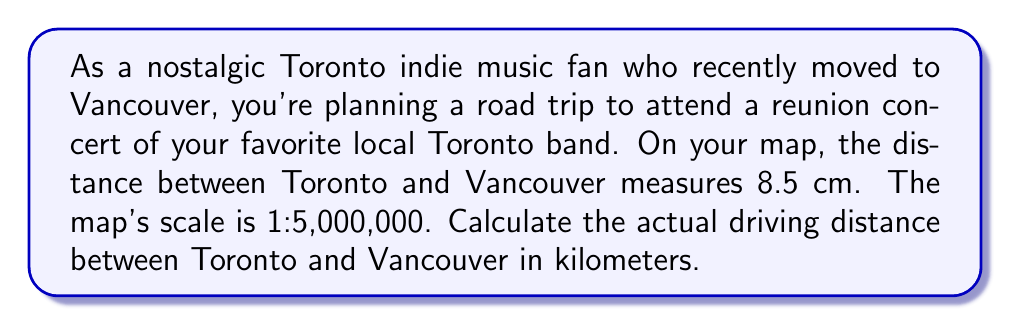Give your solution to this math problem. To solve this problem, we need to use the map scale to convert the measured distance on the map to the actual distance in kilometers. Let's break it down step-by-step:

1. Understand the map scale:
   The scale 1:5,000,000 means that 1 unit on the map represents 5,000,000 units in real life.

2. Convert the map measurement to real-life distance:
   - Map distance = 8.5 cm
   - Real distance = 8.5 × 5,000,000 cm

3. Calculate the real distance:
   $$ \text{Real distance} = 8.5 \times 5,000,000 = 42,500,000 \text{ cm} $$

4. Convert centimeters to kilometers:
   $$ 42,500,000 \text{ cm} = \frac{42,500,000}{100,000} \text{ km} = 425 \text{ km} $$

Therefore, the actual driving distance between Toronto and Vancouver is 425 km.
Answer: 425 km 